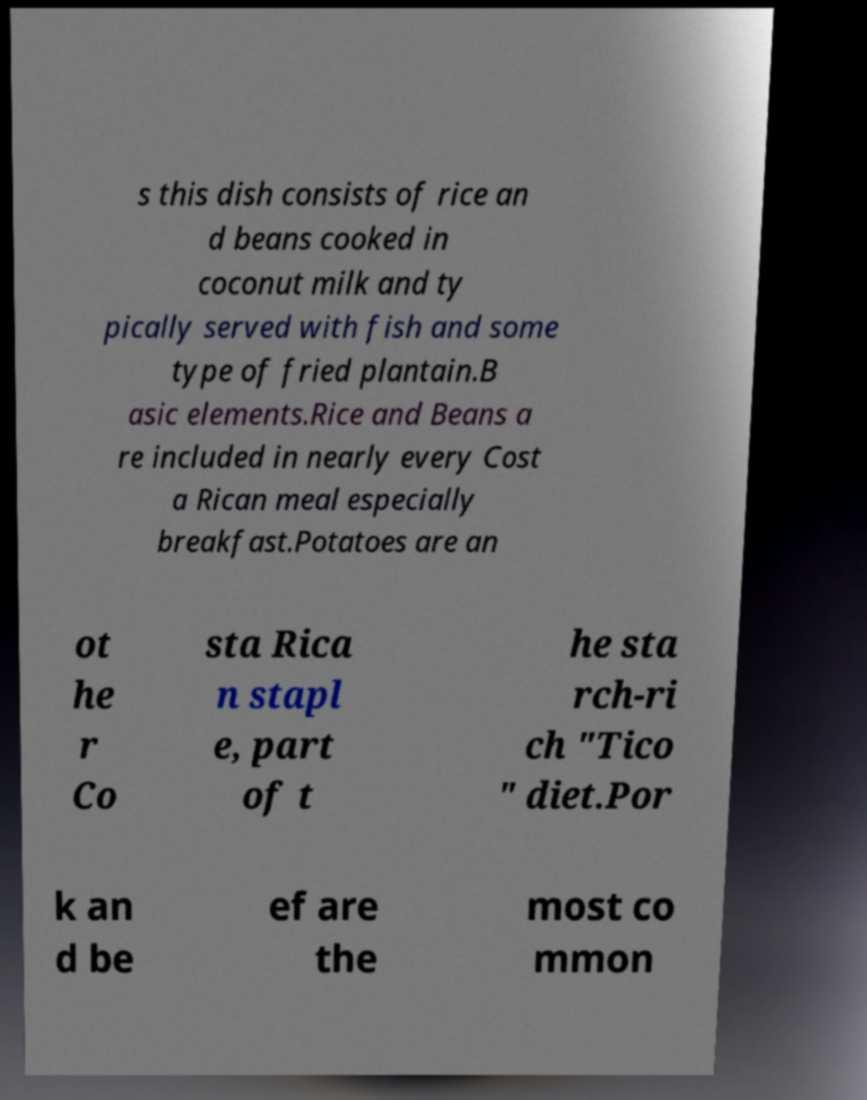Please identify and transcribe the text found in this image. s this dish consists of rice an d beans cooked in coconut milk and ty pically served with fish and some type of fried plantain.B asic elements.Rice and Beans a re included in nearly every Cost a Rican meal especially breakfast.Potatoes are an ot he r Co sta Rica n stapl e, part of t he sta rch-ri ch "Tico " diet.Por k an d be ef are the most co mmon 